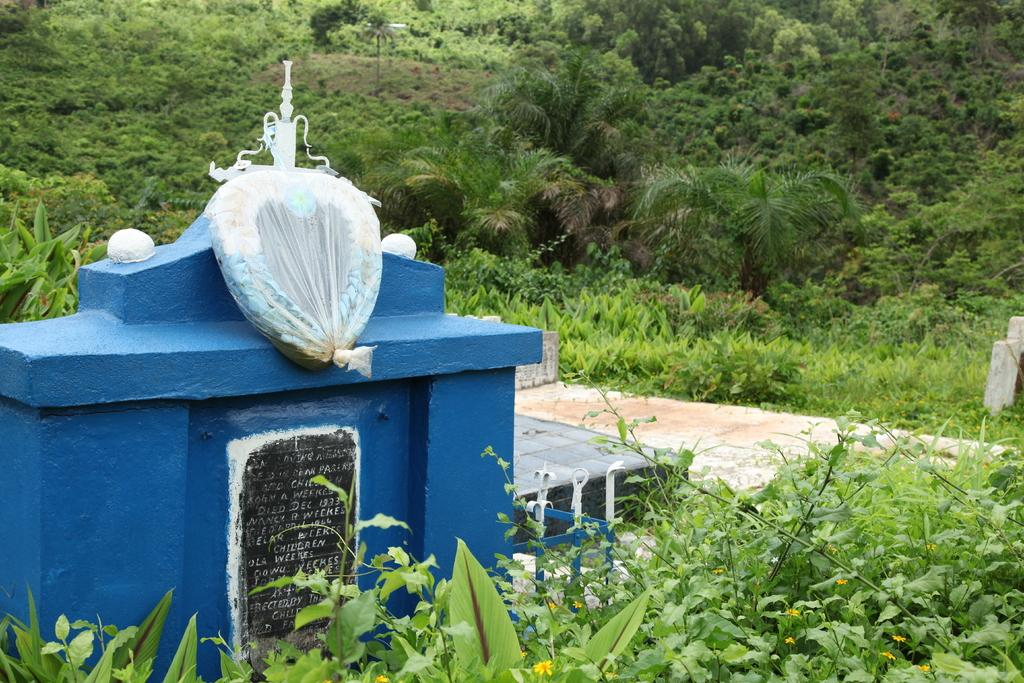What is placed on the tomb in the image? There is a bouquet on the tomb in the image. What type of vegetation can be seen in the image? There are many plants and flowers present in the image. What is the ground surface like in the image? There is grass visible in the image. Can you see a zipper on any of the plants in the image? No, there are no zippers present on the plants in the image. Is there a thumb visible on any of the flowers in the image? No, there are no thumbs present on the flowers in the image. 